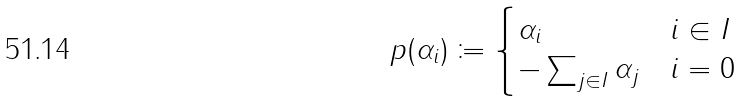Convert formula to latex. <formula><loc_0><loc_0><loc_500><loc_500>p ( \alpha _ { i } ) \coloneqq \begin{cases} \alpha _ { i } & i \in I \\ - \sum _ { j \in I } \alpha _ { j } & i = 0 \end{cases}</formula> 